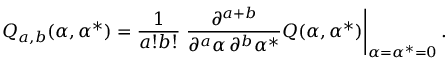<formula> <loc_0><loc_0><loc_500><loc_500>Q _ { a , b } ( \alpha , \alpha ^ { * } ) = \frac { 1 } { a ! b ! } \frac { \partial ^ { a + b } } { \partial ^ { a } \alpha \, \partial ^ { b } \alpha ^ { * } } Q ( \alpha , \alpha ^ { * } ) \right | _ { \alpha = \alpha ^ { * } = 0 } .</formula> 